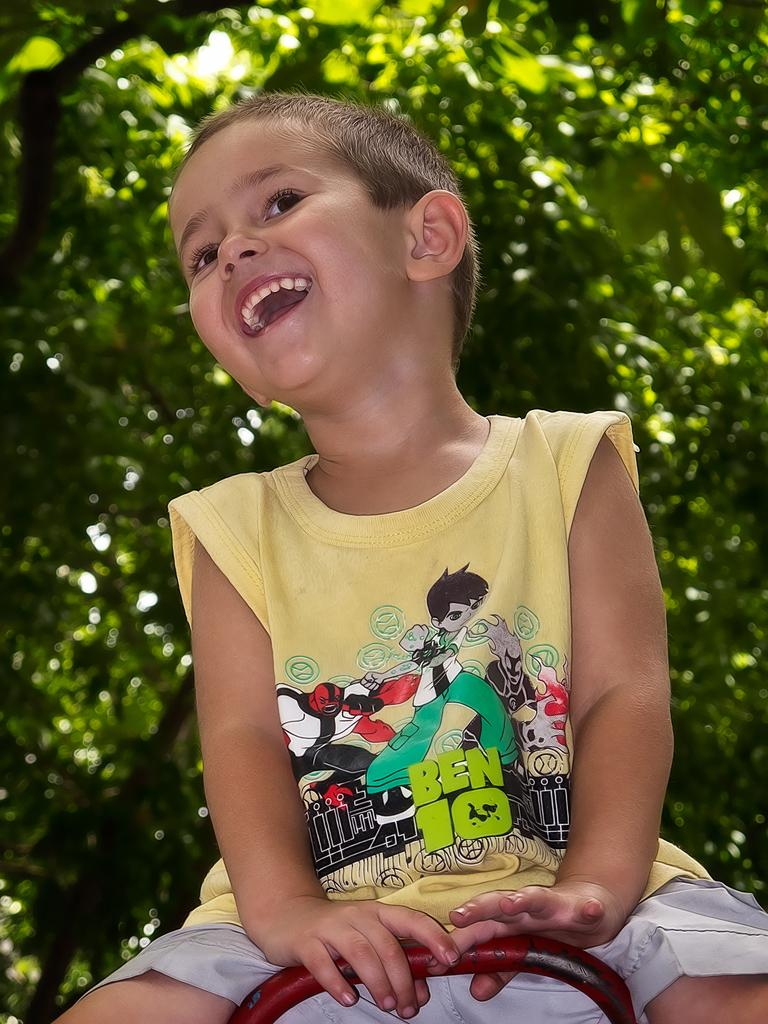What is the main subject of the image? There is a child in the image. What is the child doing in the image? The child is sitting and smiling. What can be seen in the background of the image? There are trees visible in the background of the image. What type of disease is the child suffering from in the image? There is no indication of any disease in the image; the child is simply sitting and smiling. 